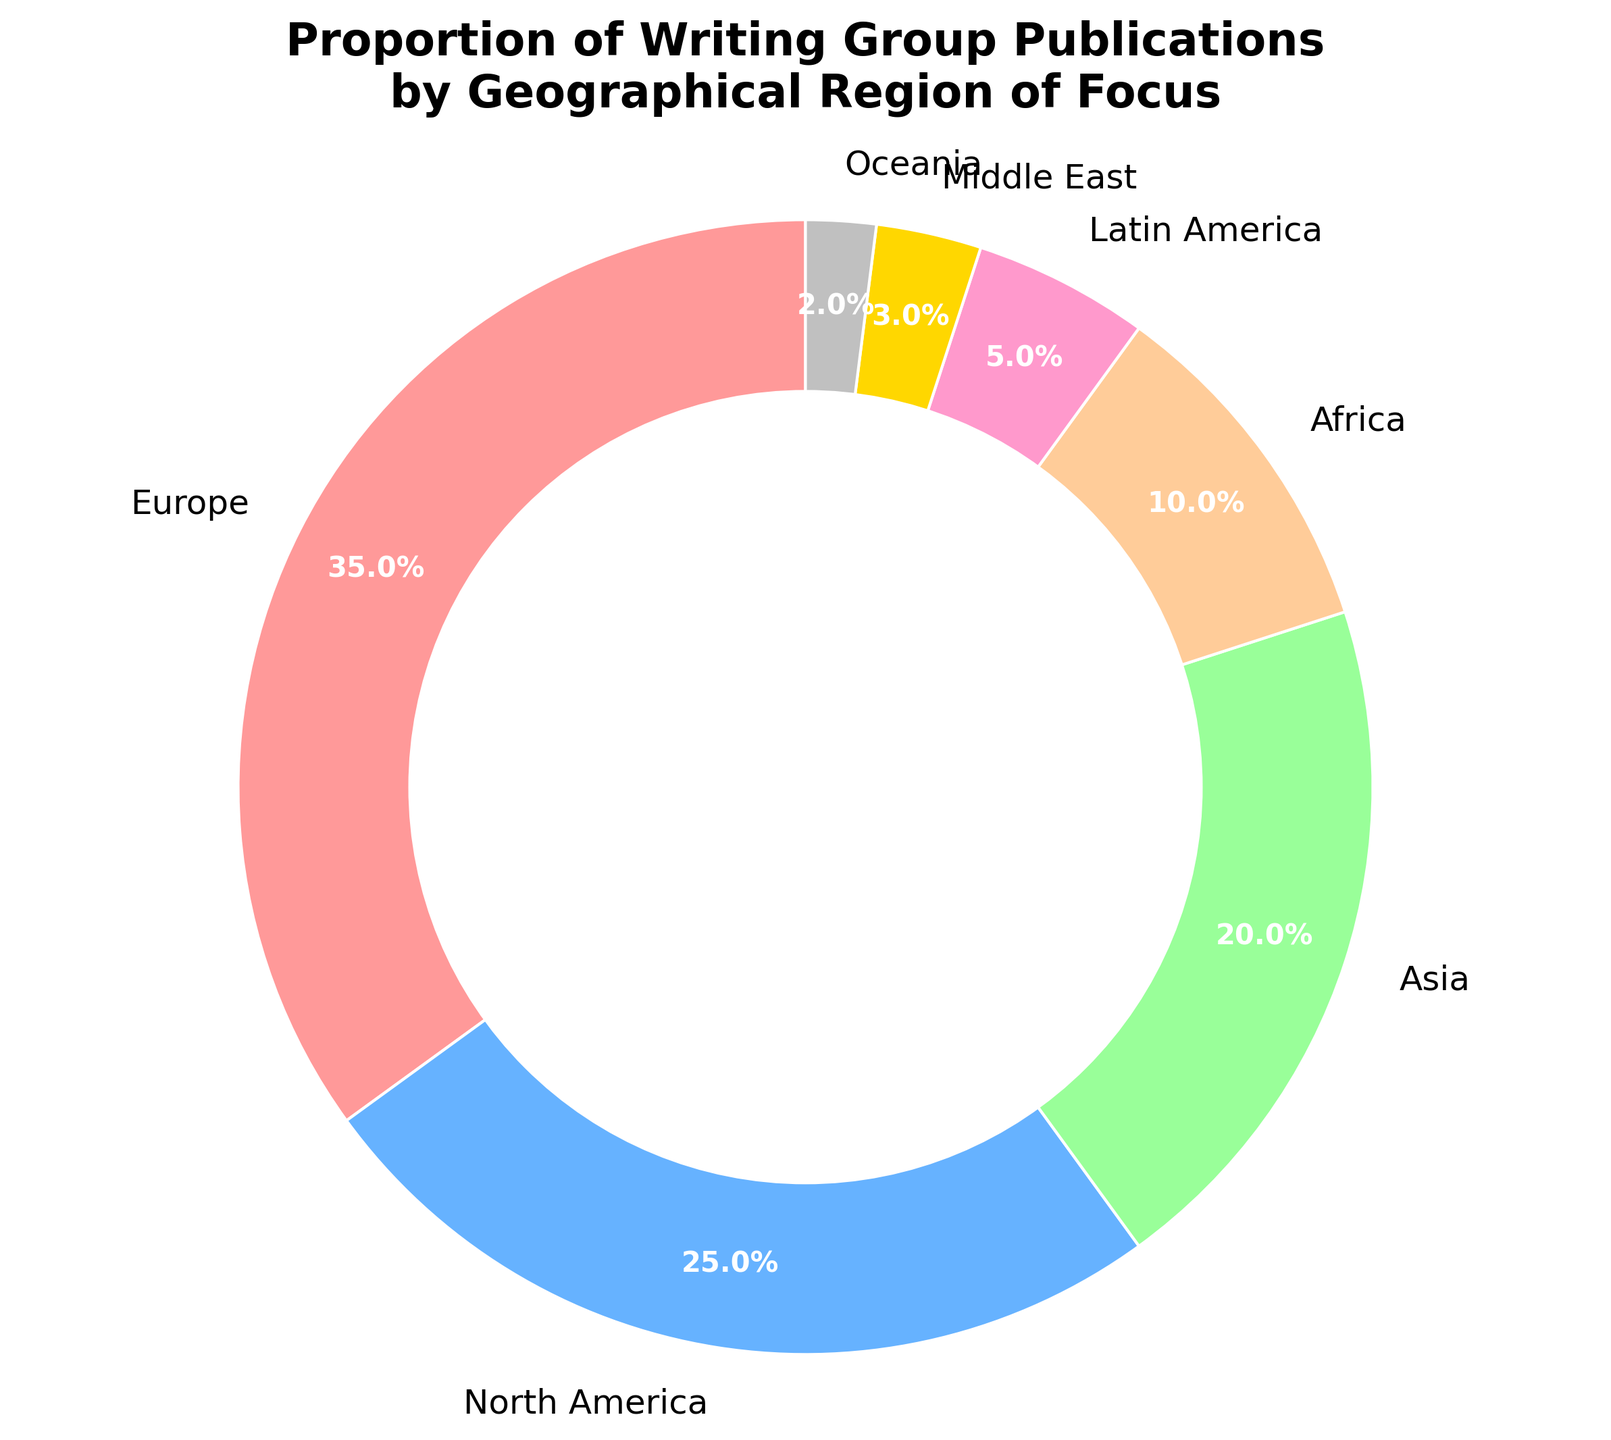What's the largest proportion of writing group publications for any geographical region? The largest section of the pie chart represents Europe. Reading the corresponding label, we see that Europe has a 35% proportion of writing group publications, which is the largest.
Answer: Europe, 35% How much greater is the proportion for Europe compared to North America? Europe has a proportion of 35%, while North America has a 25% proportion. Subtracting 25% from 35% gives us the difference. 35% - 25% = 10%.
Answer: 10% Which region has the smallest proportion? Looking at the pie chart, the smallest section belongs to Oceania. The label shows Oceania with a 2% proportion.
Answer: Oceania, 2% What is the combined proportion of writing group publications for Africa and Latin America? Africa has a proportion of 10%, and Latin America has 5%. Adding these figures together gives us 10% + 5% = 15%.
Answer: 15% If we combined Asia and the Middle East, what would be their combined proportion of publications? Asia has a proportion of 20%, and the Middle East has 3%. Adding these figures together gives us 20% + 3% = 23%.
Answer: 23% Is the proportion of publications focused on Asia greater or less than the combined proportion of Latin America and Oceania? Latin America has 5%, and Oceania has 2%. Combining these gives 5% + 2% = 7%. Since Asia has a 20% proportion, it is greater than the combined 7% for Latin America and Oceania.
Answer: Greater What is the average proportion of publications across all regions? Adding all the proportions (35 + 25 + 20 + 10 + 5 + 3 + 2) gives a sum of 100. Dividing by the number of regions (7) gives the average: 100 / 7 = approximately 14.3%.
Answer: Approximately 14.3% Compare the proportion of publications in the Middle East to Oceania. Which region has a higher proportion? The Middle East has a proportion of 3%, while Oceania has a 2% proportion. Since 3% is greater than 2%, the Middle East has a higher proportion.
Answer: Middle East Which regions have a proportion of publications greater than 10%? Reviewing the pie chart, regions with greater than 10% proportions are Europe (35%), North America (25%), and Asia (20%).
Answer: Europe, North America, Asia If the proportions for North America doubled, what would be the new proportion for North America, and how would it compare to Europe? If North America's proportion doubles, it goes from 25% to 50%. Comparing this to Europe's 35%, North America would then have a higher proportion.
Answer: North America, 50%, higher 